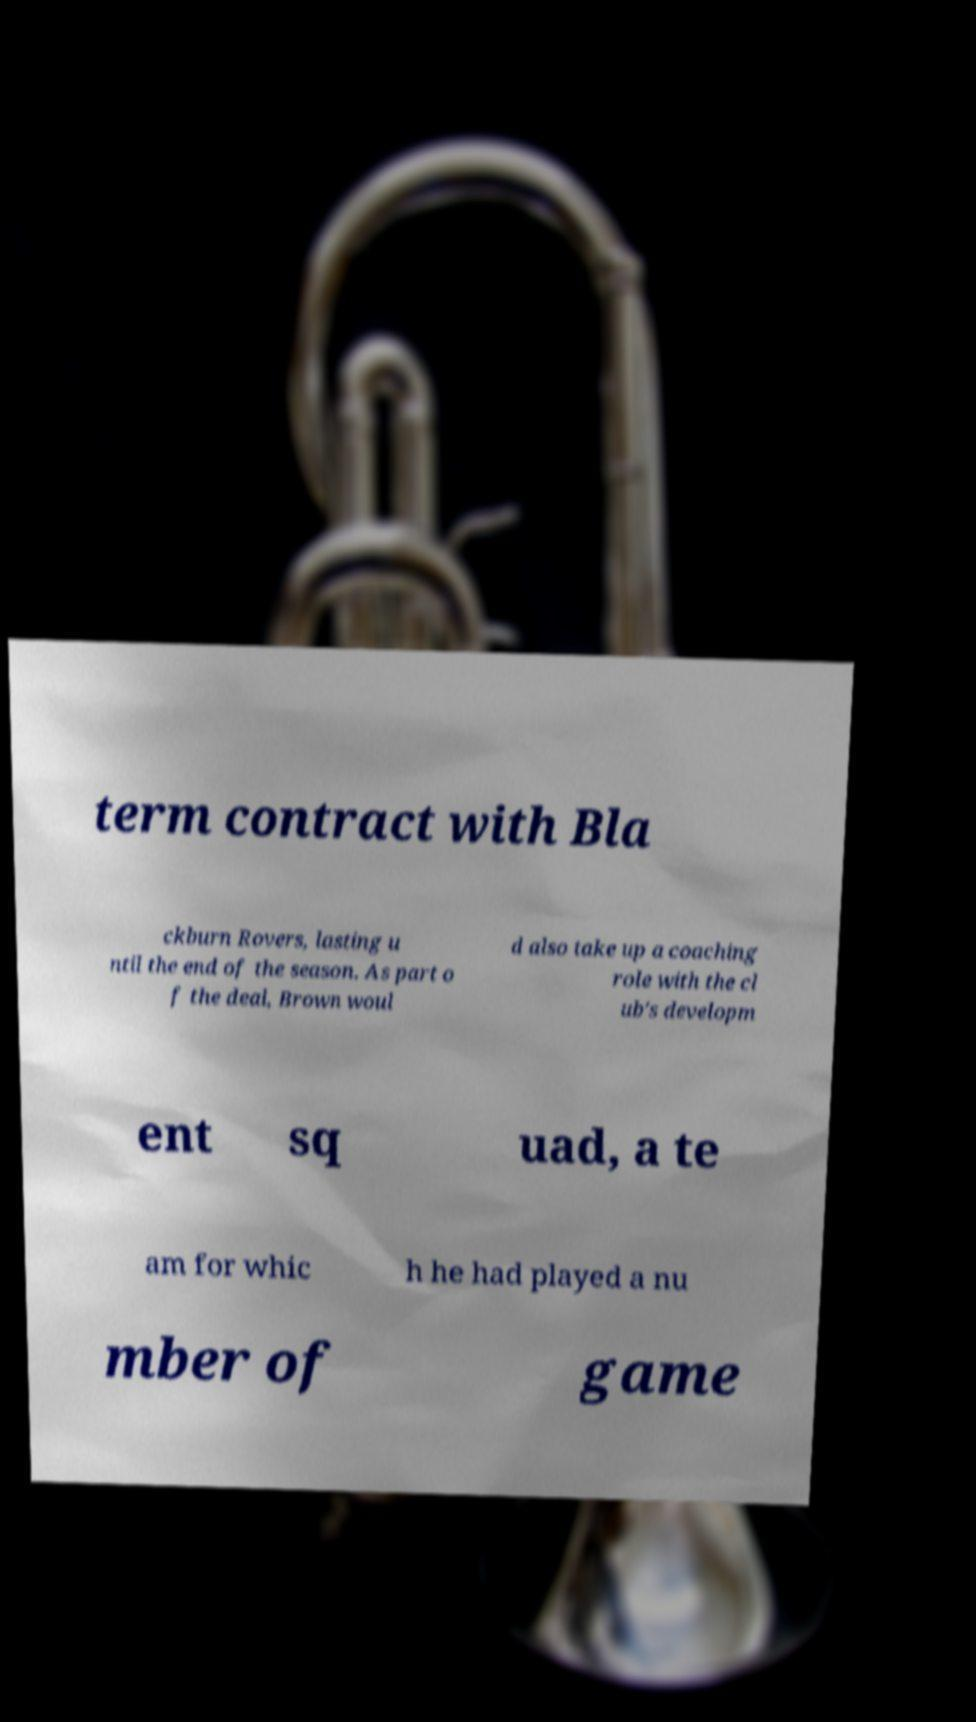Please read and relay the text visible in this image. What does it say? term contract with Bla ckburn Rovers, lasting u ntil the end of the season. As part o f the deal, Brown woul d also take up a coaching role with the cl ub's developm ent sq uad, a te am for whic h he had played a nu mber of game 